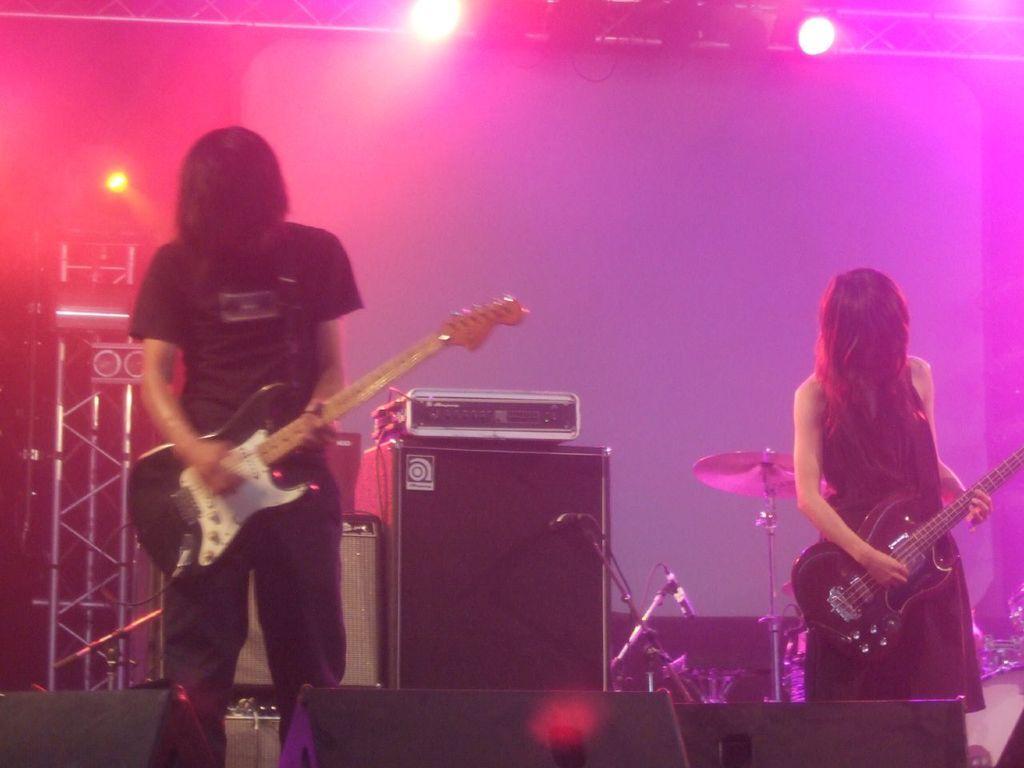Can you describe this image briefly? in this image the two persons are playing the guitar on the stage there are many instruments are there and both of them are wearing a black color and the back ground is dark. 